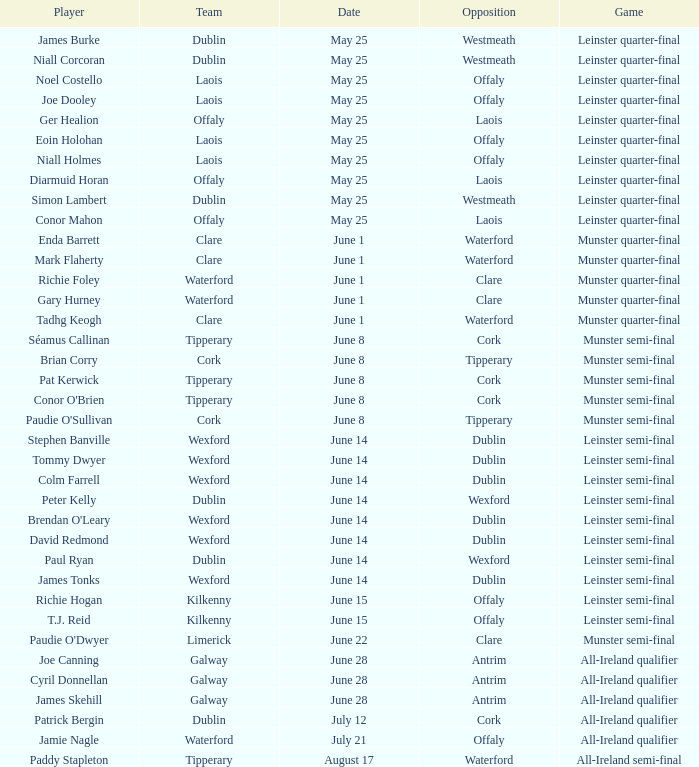What game did Eoin Holohan play in? Leinster quarter-final. Would you be able to parse every entry in this table? {'header': ['Player', 'Team', 'Date', 'Opposition', 'Game'], 'rows': [['James Burke', 'Dublin', 'May 25', 'Westmeath', 'Leinster quarter-final'], ['Niall Corcoran', 'Dublin', 'May 25', 'Westmeath', 'Leinster quarter-final'], ['Noel Costello', 'Laois', 'May 25', 'Offaly', 'Leinster quarter-final'], ['Joe Dooley', 'Laois', 'May 25', 'Offaly', 'Leinster quarter-final'], ['Ger Healion', 'Offaly', 'May 25', 'Laois', 'Leinster quarter-final'], ['Eoin Holohan', 'Laois', 'May 25', 'Offaly', 'Leinster quarter-final'], ['Niall Holmes', 'Laois', 'May 25', 'Offaly', 'Leinster quarter-final'], ['Diarmuid Horan', 'Offaly', 'May 25', 'Laois', 'Leinster quarter-final'], ['Simon Lambert', 'Dublin', 'May 25', 'Westmeath', 'Leinster quarter-final'], ['Conor Mahon', 'Offaly', 'May 25', 'Laois', 'Leinster quarter-final'], ['Enda Barrett', 'Clare', 'June 1', 'Waterford', 'Munster quarter-final'], ['Mark Flaherty', 'Clare', 'June 1', 'Waterford', 'Munster quarter-final'], ['Richie Foley', 'Waterford', 'June 1', 'Clare', 'Munster quarter-final'], ['Gary Hurney', 'Waterford', 'June 1', 'Clare', 'Munster quarter-final'], ['Tadhg Keogh', 'Clare', 'June 1', 'Waterford', 'Munster quarter-final'], ['Séamus Callinan', 'Tipperary', 'June 8', 'Cork', 'Munster semi-final'], ['Brian Corry', 'Cork', 'June 8', 'Tipperary', 'Munster semi-final'], ['Pat Kerwick', 'Tipperary', 'June 8', 'Cork', 'Munster semi-final'], ["Conor O'Brien", 'Tipperary', 'June 8', 'Cork', 'Munster semi-final'], ["Paudie O'Sullivan", 'Cork', 'June 8', 'Tipperary', 'Munster semi-final'], ['Stephen Banville', 'Wexford', 'June 14', 'Dublin', 'Leinster semi-final'], ['Tommy Dwyer', 'Wexford', 'June 14', 'Dublin', 'Leinster semi-final'], ['Colm Farrell', 'Wexford', 'June 14', 'Dublin', 'Leinster semi-final'], ['Peter Kelly', 'Dublin', 'June 14', 'Wexford', 'Leinster semi-final'], ["Brendan O'Leary", 'Wexford', 'June 14', 'Dublin', 'Leinster semi-final'], ['David Redmond', 'Wexford', 'June 14', 'Dublin', 'Leinster semi-final'], ['Paul Ryan', 'Dublin', 'June 14', 'Wexford', 'Leinster semi-final'], ['James Tonks', 'Wexford', 'June 14', 'Dublin', 'Leinster semi-final'], ['Richie Hogan', 'Kilkenny', 'June 15', 'Offaly', 'Leinster semi-final'], ['T.J. Reid', 'Kilkenny', 'June 15', 'Offaly', 'Leinster semi-final'], ["Paudie O'Dwyer", 'Limerick', 'June 22', 'Clare', 'Munster semi-final'], ['Joe Canning', 'Galway', 'June 28', 'Antrim', 'All-Ireland qualifier'], ['Cyril Donnellan', 'Galway', 'June 28', 'Antrim', 'All-Ireland qualifier'], ['James Skehill', 'Galway', 'June 28', 'Antrim', 'All-Ireland qualifier'], ['Patrick Bergin', 'Dublin', 'July 12', 'Cork', 'All-Ireland qualifier'], ['Jamie Nagle', 'Waterford', 'July 21', 'Offaly', 'All-Ireland qualifier'], ['Paddy Stapleton', 'Tipperary', 'August 17', 'Waterford', 'All-Ireland semi-final']]} 